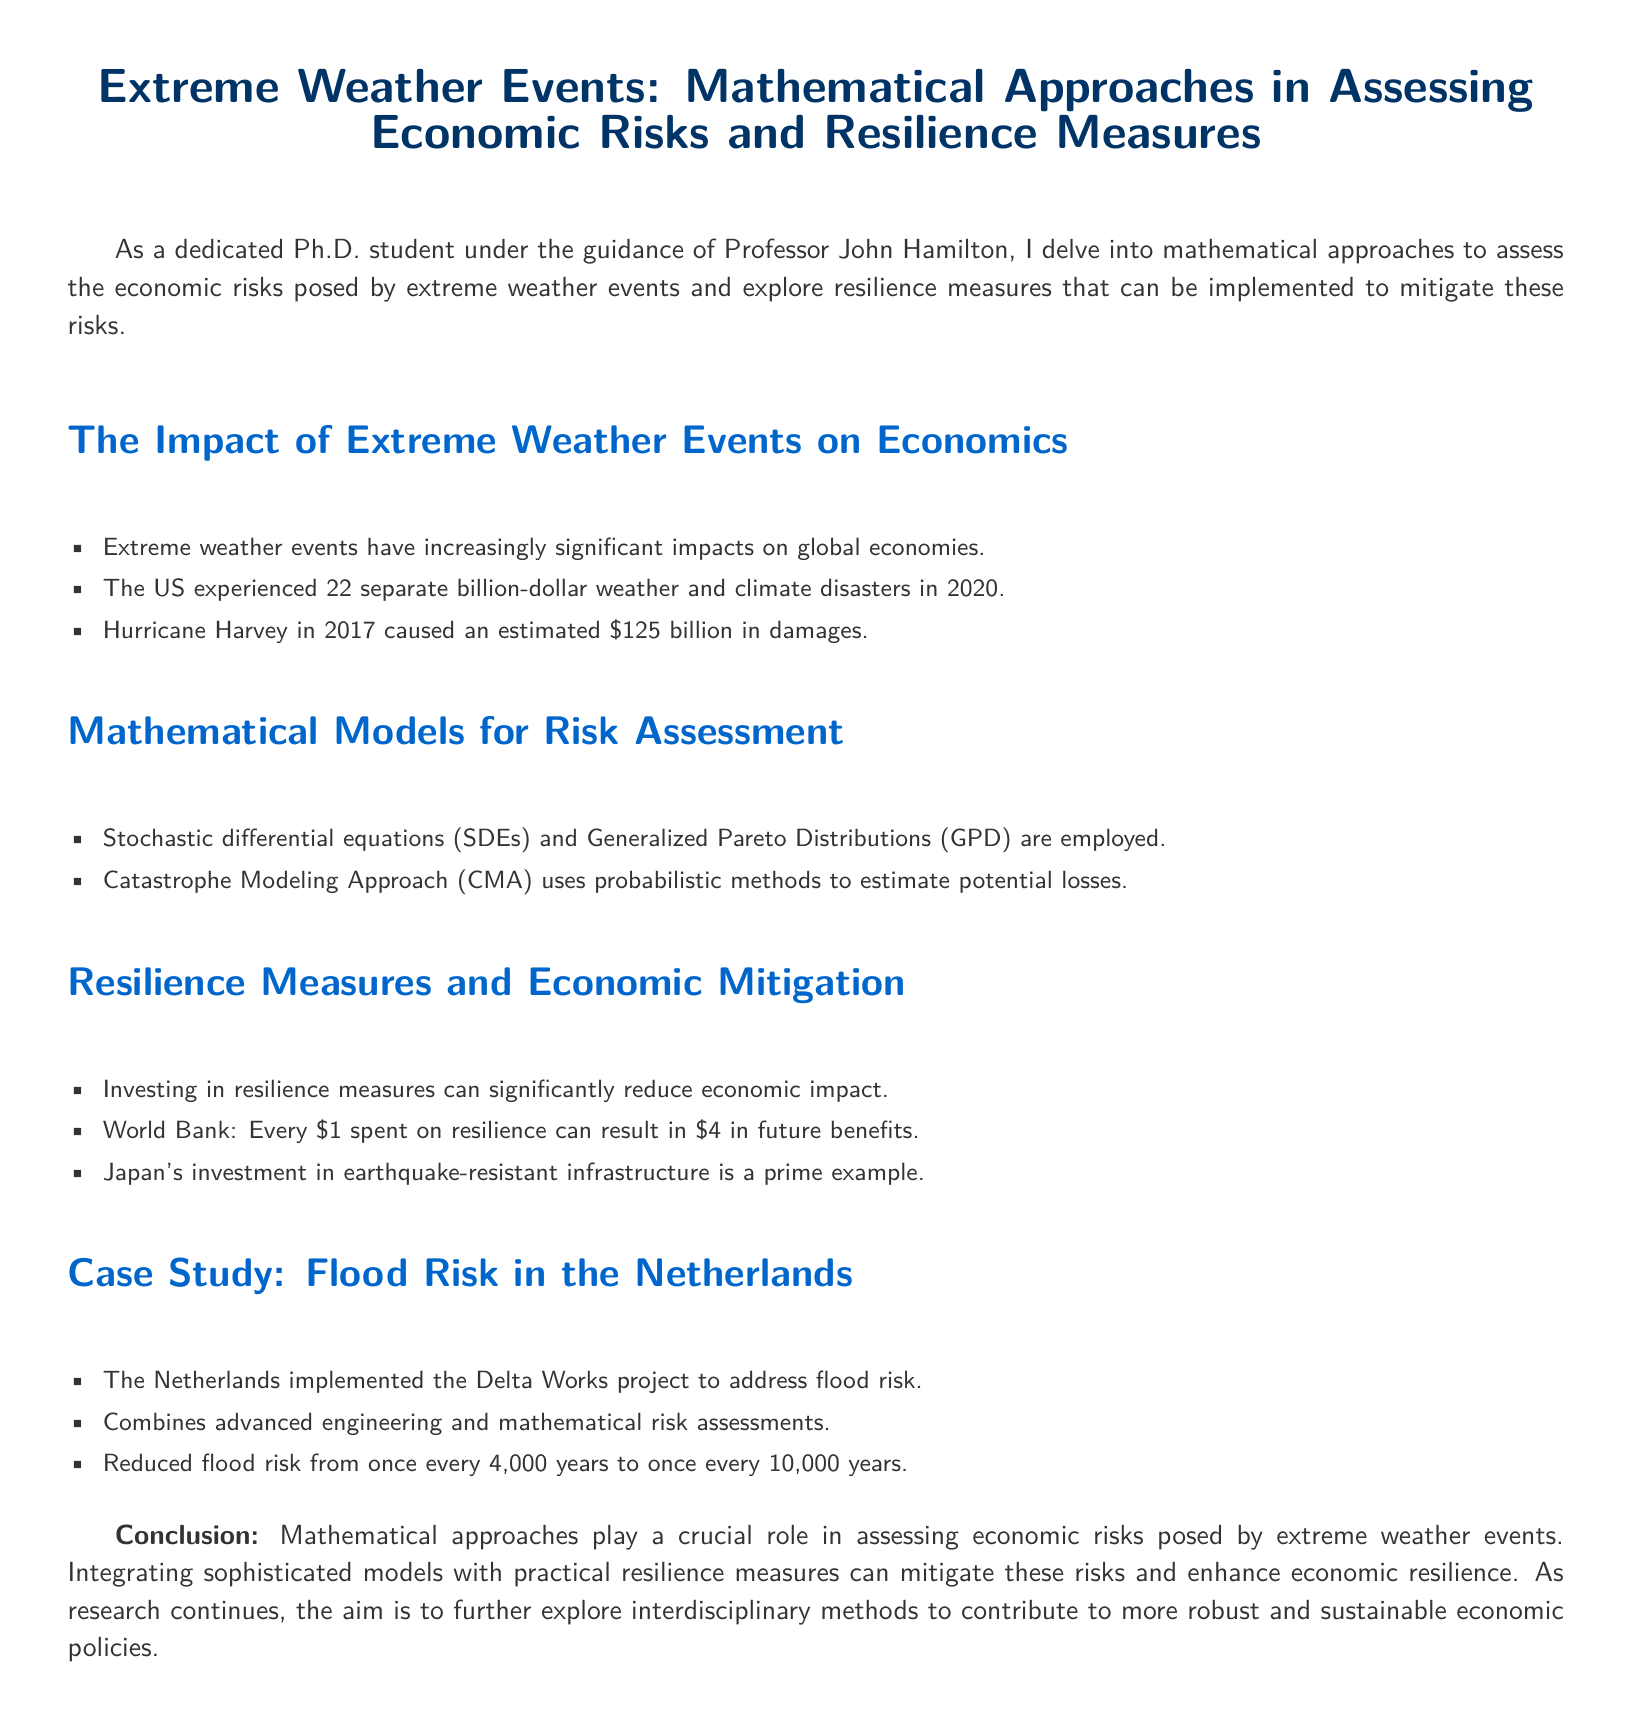What is the estimated damage caused by Hurricane Harvey? Hurricane Harvey in 2017 caused an estimated \$125 billion in damages.
Answer: \$125 billion How many billion-dollar weather disasters occurred in the US in 2020? The US experienced 22 separate billion-dollar weather and climate disasters in 2020.
Answer: 22 What mathematical model uses probabilistic methods to estimate potential losses? The Catastrophe Modeling Approach (CMA) uses probabilistic methods to estimate potential losses.
Answer: Catastrophe Modeling Approach (CMA) What is the benefit-to-cost ratio of investing in resilience measures according to the World Bank? Every \$1 spent on resilience can result in \$4 in future benefits according to the World Bank.
Answer: \$4 What project did the Netherlands implement to address flood risk? The Netherlands implemented the Delta Works project to address flood risk.
Answer: Delta Works What is the reduced flood risk frequency achieved by the Delta Works project? Reduced flood risk from once every 4,000 years to once every 10,000 years.
Answer: once every 10,000 years What types of mathematical models are employed for risk assessment? Stochastic differential equations (SDEs) and Generalized Pareto Distributions (GPD) are employed.
Answer: Stochastic differential equations (SDEs) and Generalized Pareto Distributions (GPD) What is the primary example cited for Japan's resilience investment? Japan's investment in earthquake-resistant infrastructure is a prime example.
Answer: earthquake-resistant infrastructure What is the overall conclusion about the role of mathematical approaches? Mathematical approaches play a crucial role in assessing economic risks posed by extreme weather events.
Answer: crucial role 